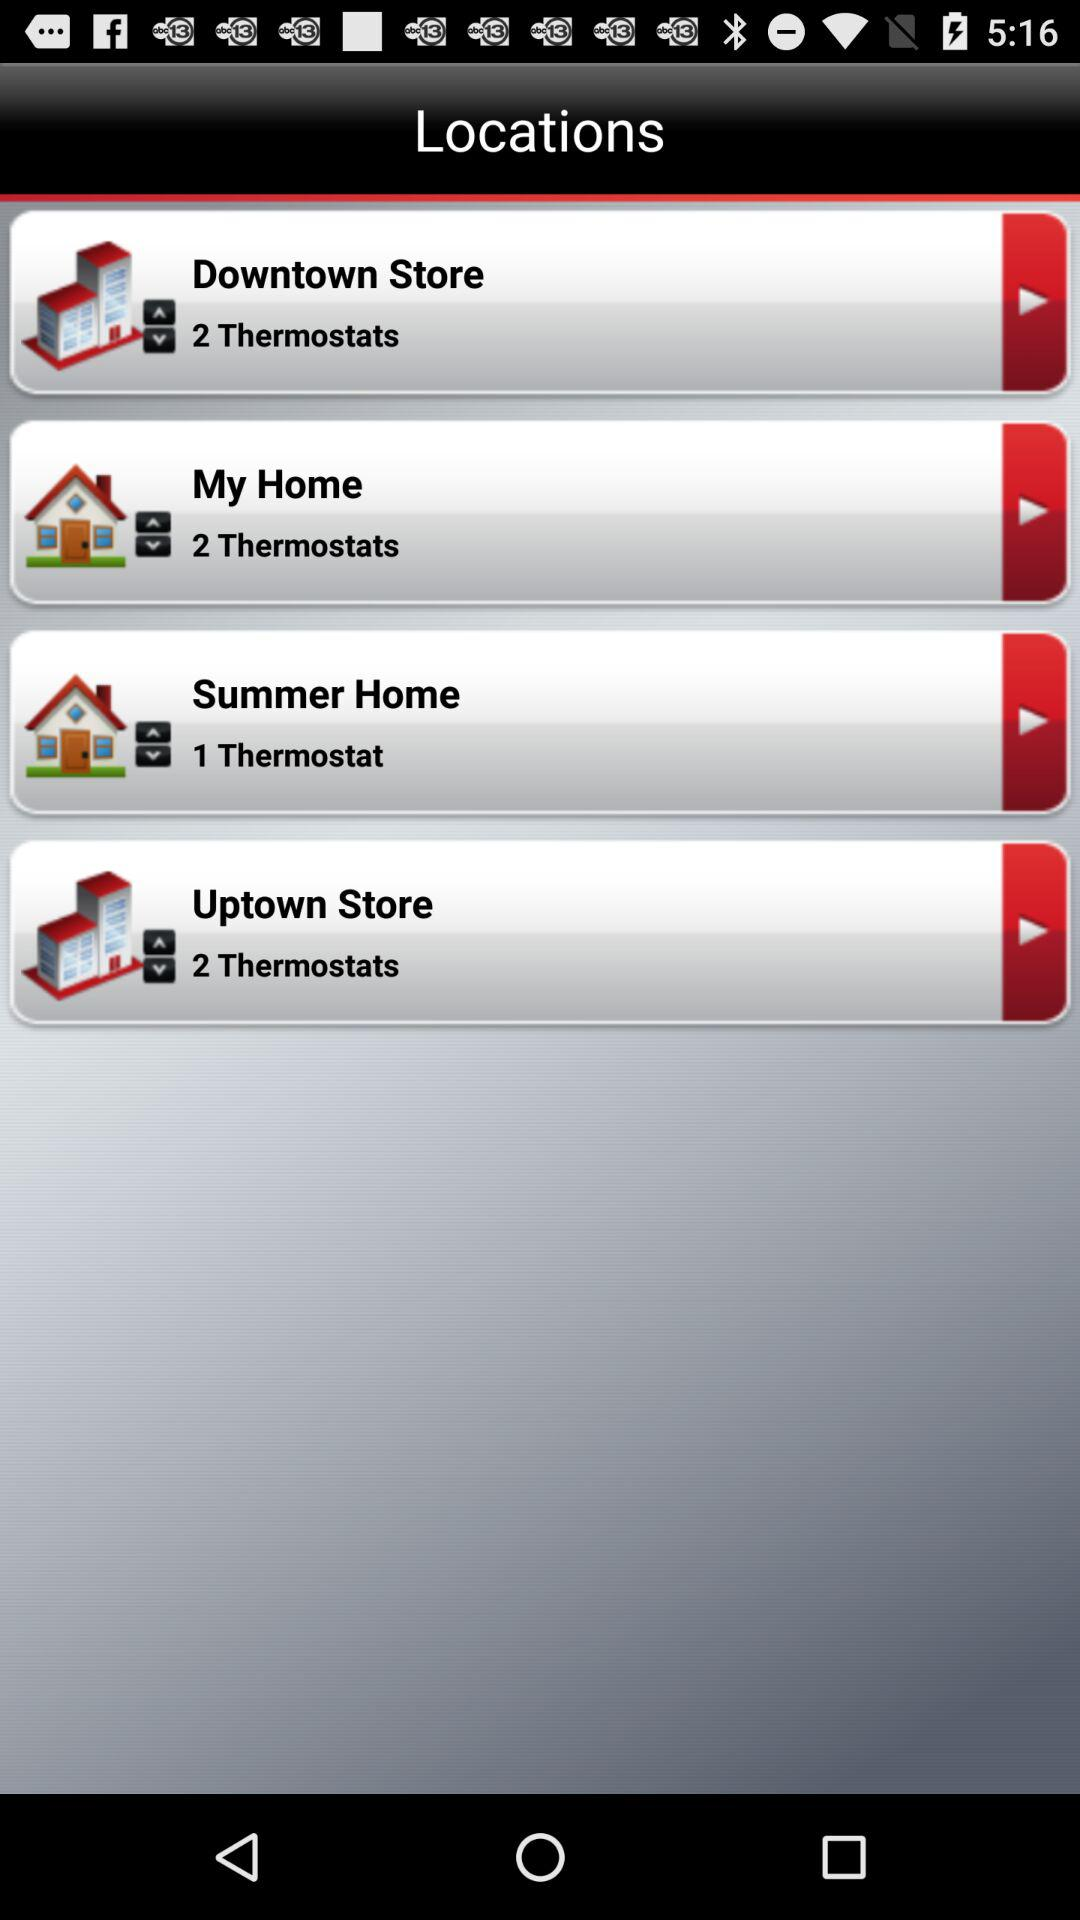At 1 thermostat, which location is present? The location is Summer Home. 